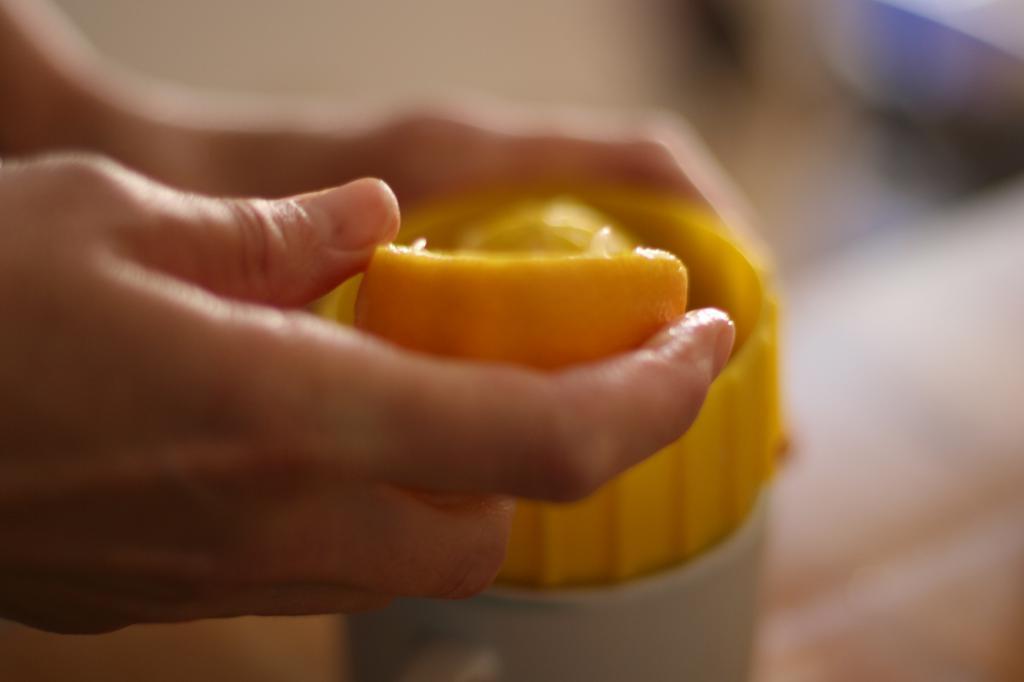Could you give a brief overview of what you see in this image? In this image we can see a person holding the orange in one hand and juicer in the other hand. Background of the image is blur. 